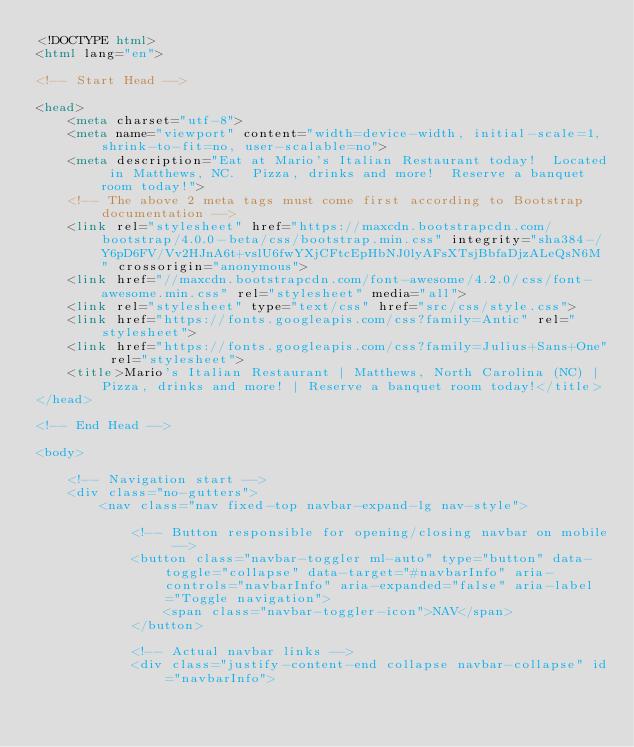<code> <loc_0><loc_0><loc_500><loc_500><_HTML_><!DOCTYPE html>
<html lang="en">

<!-- Start Head -->  
    
<head>
    <meta charset="utf-8">
    <meta name="viewport" content="width=device-width, initial-scale=1, shrink-to-fit=no, user-scalable=no">
    <meta description="Eat at Mario's Italian Restaurant today!  Located in Matthews, NC.  Pizza, drinks and more!  Reserve a banquet room today!">
    <!-- The above 2 meta tags must come first according to Bootstrap documentation -->
    <link rel="stylesheet" href="https://maxcdn.bootstrapcdn.com/bootstrap/4.0.0-beta/css/bootstrap.min.css" integrity="sha384-/Y6pD6FV/Vv2HJnA6t+vslU6fwYXjCFtcEpHbNJ0lyAFsXTsjBbfaDjzALeQsN6M" crossorigin="anonymous">
    <link href="//maxcdn.bootstrapcdn.com/font-awesome/4.2.0/css/font-awesome.min.css" rel="stylesheet" media="all">
    <link rel="stylesheet" type="text/css" href="src/css/style.css">
    <link href="https://fonts.googleapis.com/css?family=Antic" rel="stylesheet">
    <link href="https://fonts.googleapis.com/css?family=Julius+Sans+One" rel="stylesheet">
    <title>Mario's Italian Restaurant | Matthews, North Carolina (NC) | Pizza, drinks and more! | Reserve a banquet room today!</title>
</head>
    
<!-- End Head -->

<body>

    <!-- Navigation start -->
    <div class="no-gutters">
        <nav class="nav fixed-top navbar-expand-lg nav-style">

            <!-- Button responsible for opening/closing navbar on mobile -->
            <button class="navbar-toggler ml-auto" type="button" data-toggle="collapse" data-target="#navbarInfo" aria-controls="navbarInfo" aria-expanded="false" aria-label="Toggle navigation">
                <span class="navbar-toggler-icon">NAV</span>
            </button>

            <!-- Actual navbar links -->
            <div class="justify-content-end collapse navbar-collapse" id="navbarInfo"></code> 